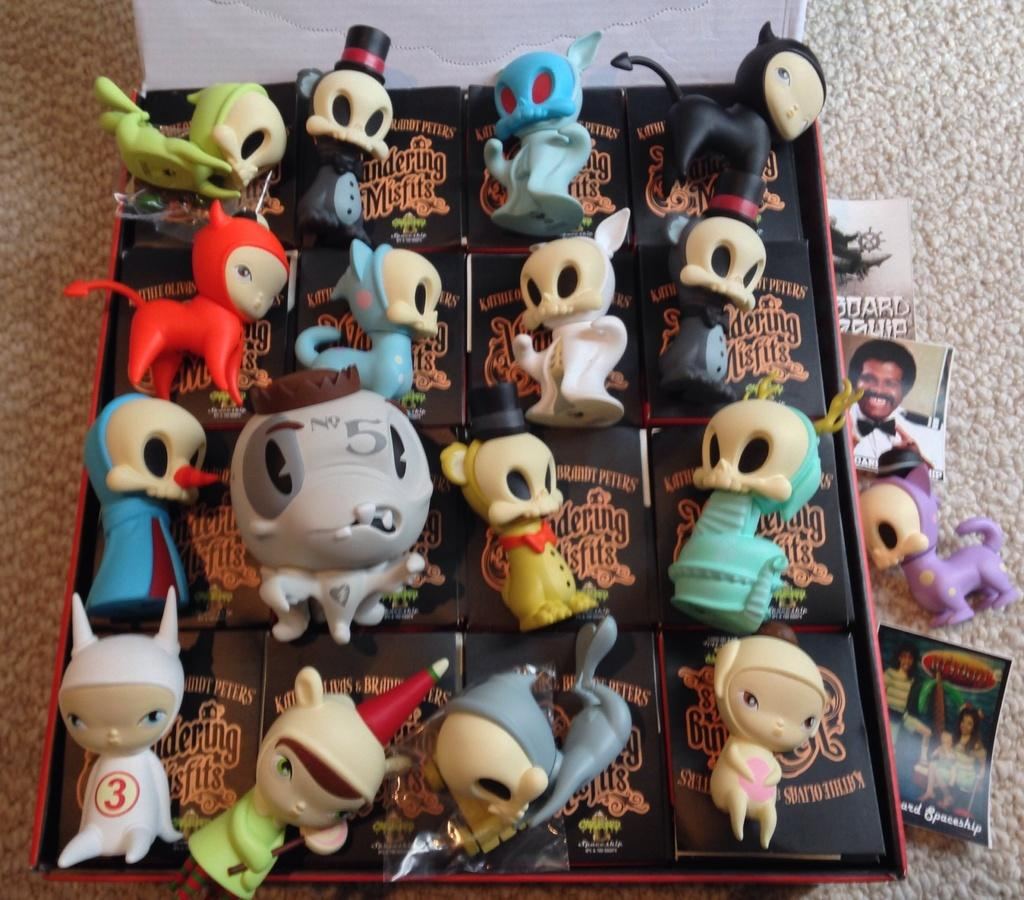What is the main object in the image? There is a box in the image. What is inside the box? The box contains many toys. Are there any other objects near the box? Yes, there are papers near the box. How much money is being stored in the box in the image? There is no mention of money in the image; the box contains toys. What type of cannon is visible near the box in the image? There is no cannon present in the image. 